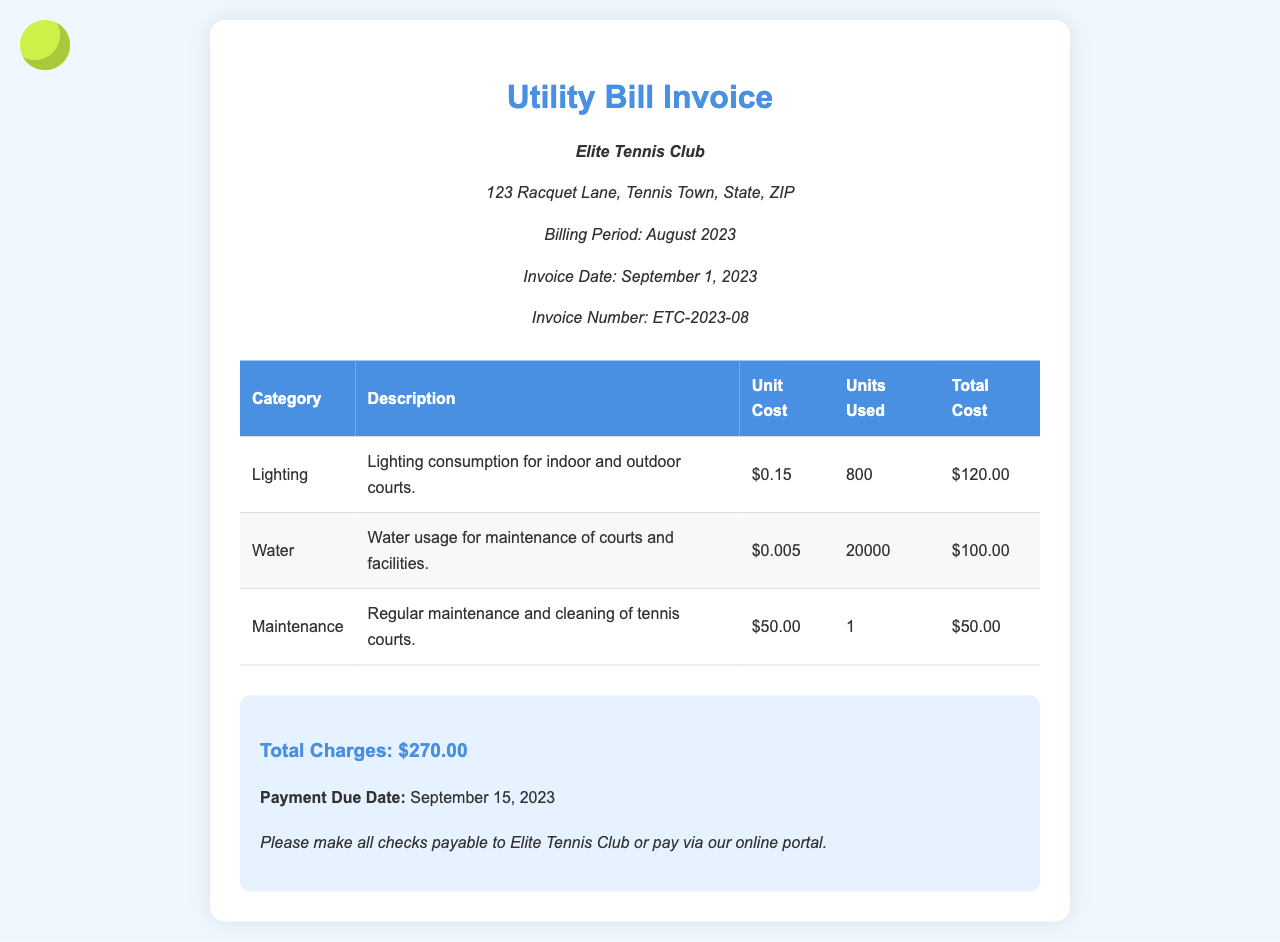What is the invoice number? The invoice number is mentioned in the document under "Invoice Number," which is ETC-2023-08.
Answer: ETC-2023-08 What is the total cost of lighting? The total cost for lighting can be found in the table under "Total Cost" for the Lighting category, which shows $120.00.
Answer: $120.00 What is the unit cost for water? The document specifies the water's unit cost in the table under "Unit Cost," which is $0.005.
Answer: $0.005 How many units of water were used? The number of units used for water is indicated in the table under "Units Used," which is 20000.
Answer: 20000 What is the payment due date? The payment due date is stated in the summary section as September 15, 2023.
Answer: September 15, 2023 What is the total charge for maintenance? The total charge for maintenance is provided in the table under "Total Cost" for the Maintenance category, which is $50.00.
Answer: $50.00 What is the total amount of the invoice? The total amount is noted in the summary as the total charges, which is $270.00.
Answer: $270.00 What facilities are covered by water usage? The description for water mentions that it is used for the maintenance of courts and facilities.
Answer: Maintenance of courts and facilities What is the description for lighting? The document describes lighting as consumption for indoor and outdoor courts.
Answer: Lighting consumption for indoor and outdoor courts 